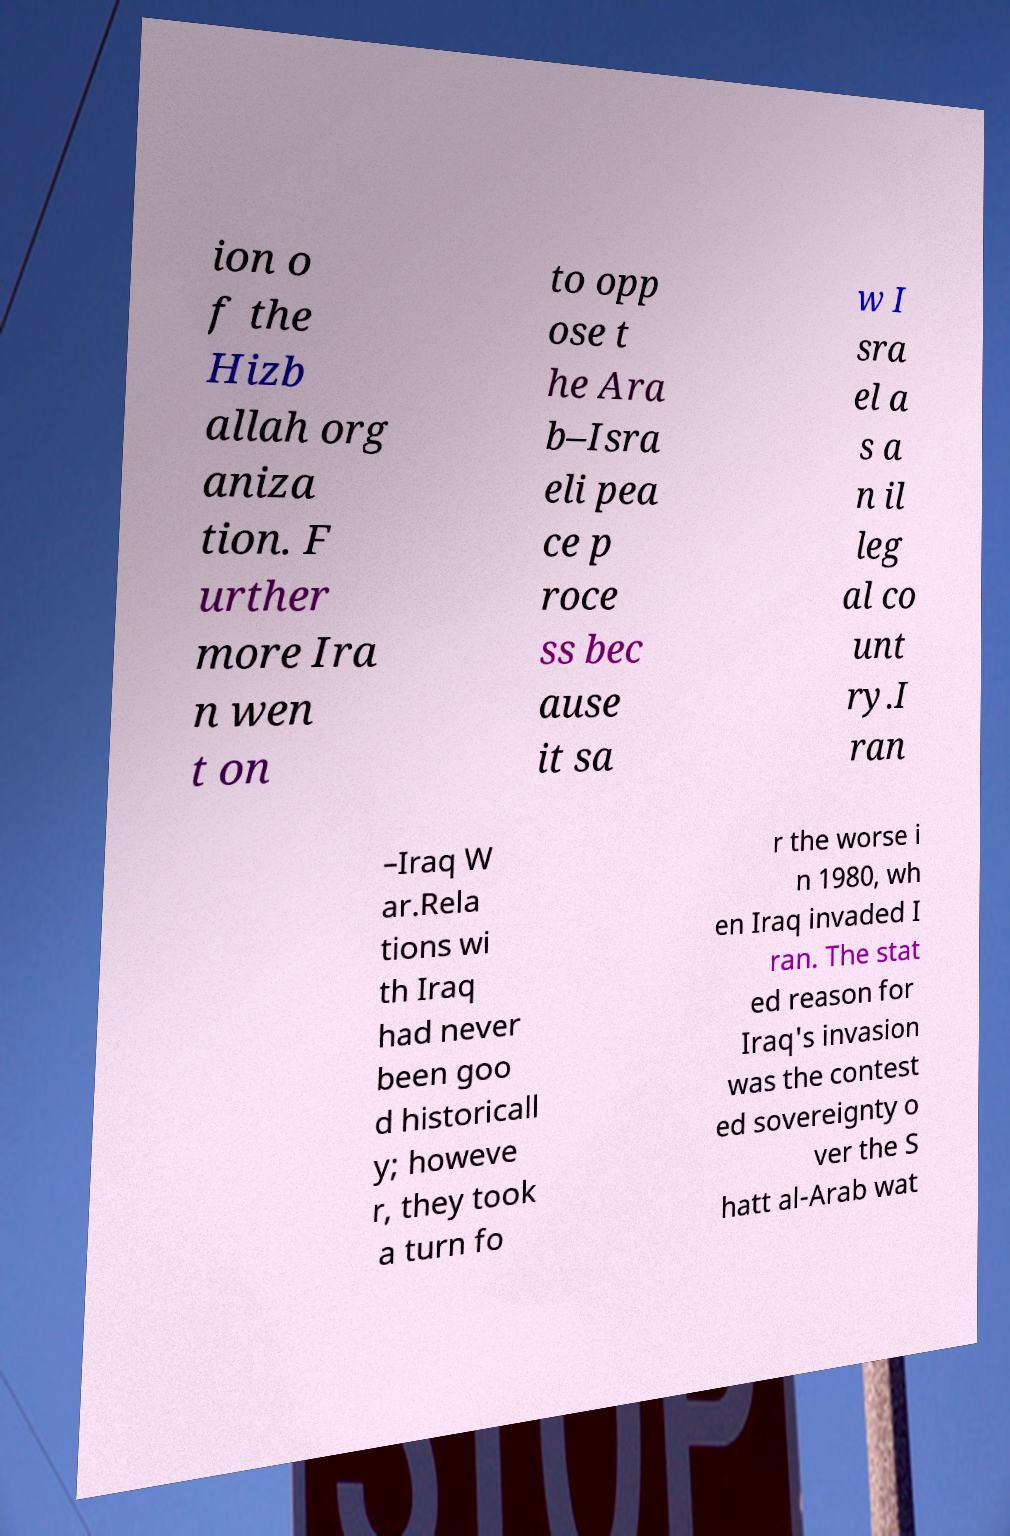Please identify and transcribe the text found in this image. ion o f the Hizb allah org aniza tion. F urther more Ira n wen t on to opp ose t he Ara b–Isra eli pea ce p roce ss bec ause it sa w I sra el a s a n il leg al co unt ry.I ran –Iraq W ar.Rela tions wi th Iraq had never been goo d historicall y; howeve r, they took a turn fo r the worse i n 1980, wh en Iraq invaded I ran. The stat ed reason for Iraq's invasion was the contest ed sovereignty o ver the S hatt al-Arab wat 